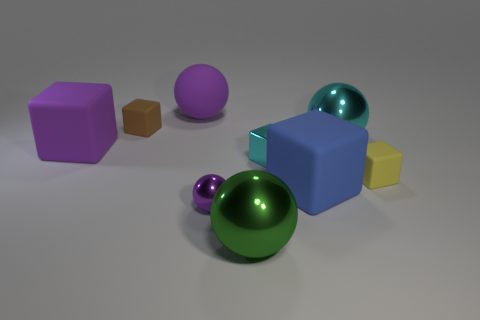How many purple spheres must be subtracted to get 1 purple spheres? 1 Subtract 2 blocks. How many blocks are left? 3 Subtract all cyan cubes. How many cubes are left? 4 Subtract all large purple blocks. How many blocks are left? 4 Subtract all blue spheres. Subtract all gray cubes. How many spheres are left? 4 Add 1 brown rubber blocks. How many objects exist? 10 Subtract all balls. How many objects are left? 5 Subtract 0 blue cylinders. How many objects are left? 9 Subtract all small cyan cubes. Subtract all brown objects. How many objects are left? 7 Add 5 spheres. How many spheres are left? 9 